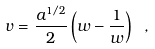Convert formula to latex. <formula><loc_0><loc_0><loc_500><loc_500>\label l { n e w r a d i a l } v = \frac { a ^ { 1 / 2 } } { 2 } \left ( w - \frac { 1 } { w } \right ) \ ,</formula> 